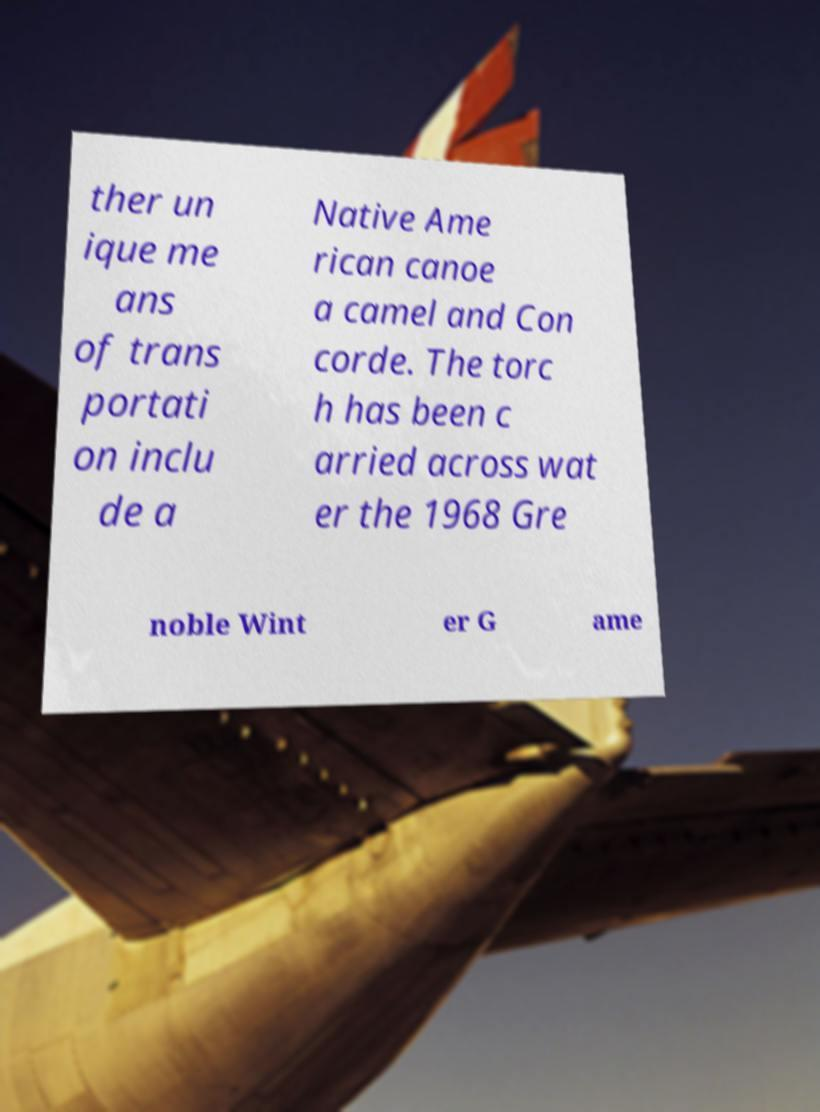There's text embedded in this image that I need extracted. Can you transcribe it verbatim? ther un ique me ans of trans portati on inclu de a Native Ame rican canoe a camel and Con corde. The torc h has been c arried across wat er the 1968 Gre noble Wint er G ame 